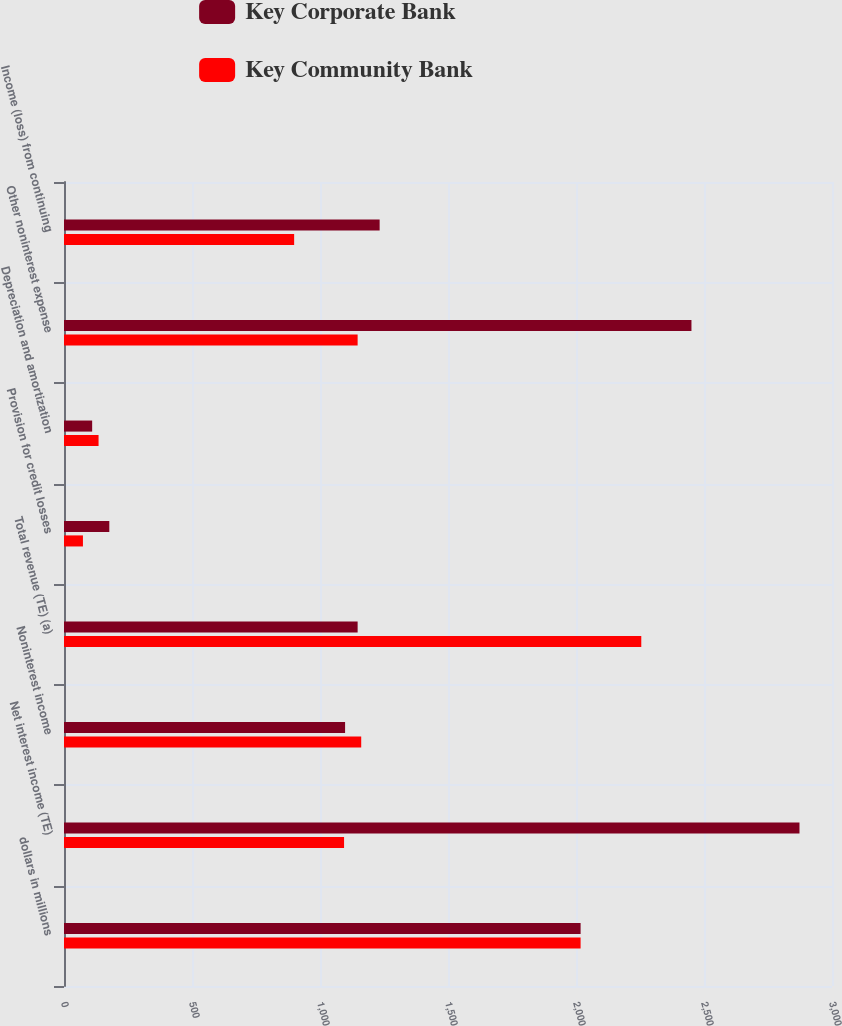<chart> <loc_0><loc_0><loc_500><loc_500><stacked_bar_chart><ecel><fcel>dollars in millions<fcel>Net interest income (TE)<fcel>Noninterest income<fcel>Total revenue (TE) (a)<fcel>Provision for credit losses<fcel>Depreciation and amortization<fcel>Other noninterest expense<fcel>Income (loss) from continuing<nl><fcel>Key Corporate Bank<fcel>2018<fcel>2873<fcel>1098<fcel>1147<fcel>177<fcel>110<fcel>2451<fcel>1233<nl><fcel>Key Community Bank<fcel>2018<fcel>1094<fcel>1161<fcel>2255<fcel>74<fcel>135<fcel>1147<fcel>899<nl></chart> 